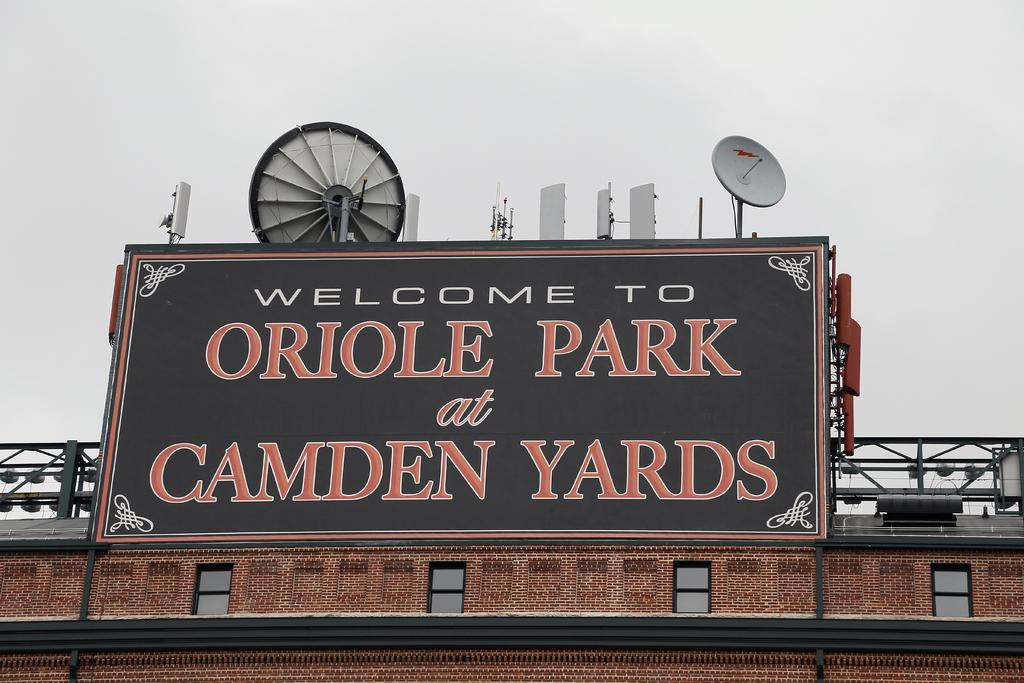Provide a one-sentence caption for the provided image. A city welcome sign sits on a building. 